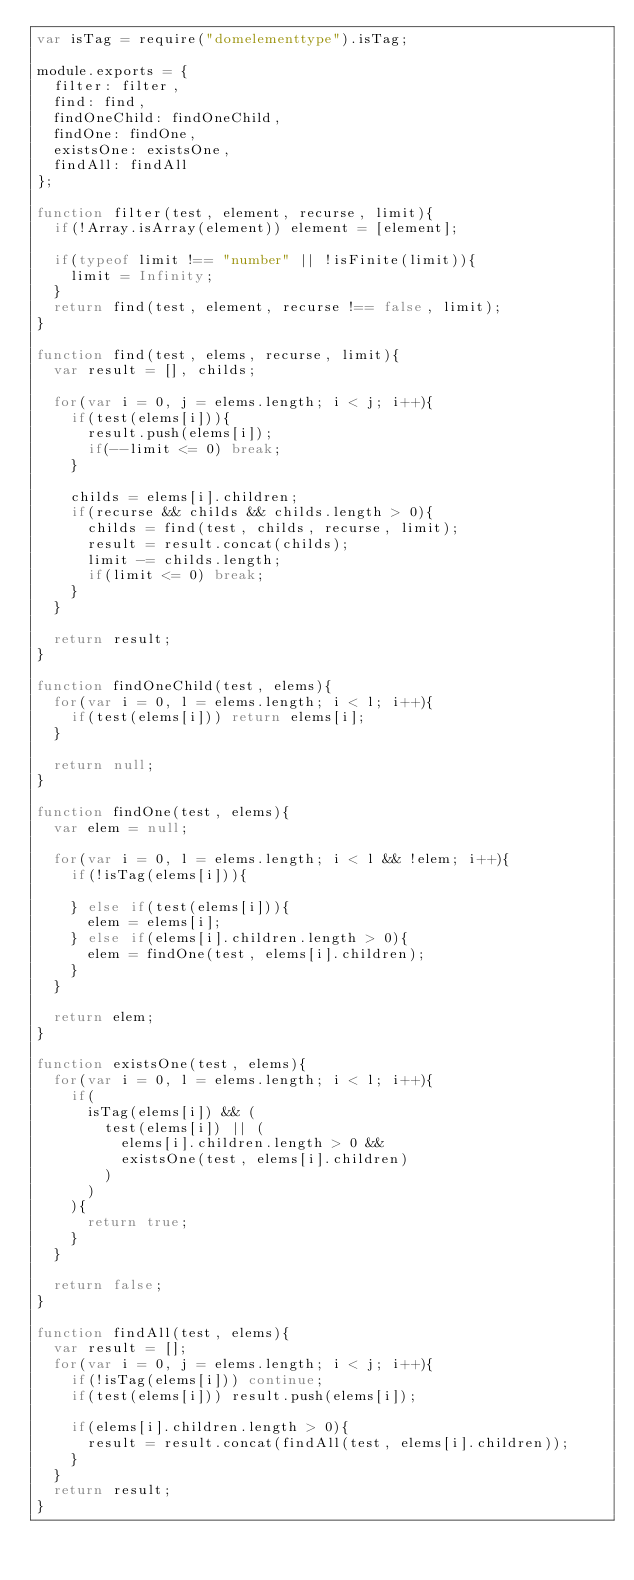Convert code to text. <code><loc_0><loc_0><loc_500><loc_500><_JavaScript_>var isTag = require("domelementtype").isTag;

module.exports = {
	filter: filter,
	find: find,
	findOneChild: findOneChild,
	findOne: findOne,
	existsOne: existsOne,
	findAll: findAll
};

function filter(test, element, recurse, limit){
	if(!Array.isArray(element)) element = [element];

	if(typeof limit !== "number" || !isFinite(limit)){
		limit = Infinity;
	}
	return find(test, element, recurse !== false, limit);
}

function find(test, elems, recurse, limit){
	var result = [], childs;

	for(var i = 0, j = elems.length; i < j; i++){
		if(test(elems[i])){
			result.push(elems[i]);
			if(--limit <= 0) break;
		}

		childs = elems[i].children;
		if(recurse && childs && childs.length > 0){
			childs = find(test, childs, recurse, limit);
			result = result.concat(childs);
			limit -= childs.length;
			if(limit <= 0) break;
		}
	}

	return result;
}

function findOneChild(test, elems){
	for(var i = 0, l = elems.length; i < l; i++){
		if(test(elems[i])) return elems[i];
	}

	return null;
}

function findOne(test, elems){
	var elem = null;

	for(var i = 0, l = elems.length; i < l && !elem; i++){
		if(!isTag(elems[i])){
			
		} else if(test(elems[i])){
			elem = elems[i];
		} else if(elems[i].children.length > 0){
			elem = findOne(test, elems[i].children);
		}
	}

	return elem;
}

function existsOne(test, elems){
	for(var i = 0, l = elems.length; i < l; i++){
		if(
			isTag(elems[i]) && (
				test(elems[i]) || (
					elems[i].children.length > 0 &&
					existsOne(test, elems[i].children)
				)
			)
		){
			return true;
		}
	}

	return false;
}

function findAll(test, elems){
	var result = [];
	for(var i = 0, j = elems.length; i < j; i++){
		if(!isTag(elems[i])) continue;
		if(test(elems[i])) result.push(elems[i]);

		if(elems[i].children.length > 0){
			result = result.concat(findAll(test, elems[i].children));
		}
	}
	return result;
}
</code> 